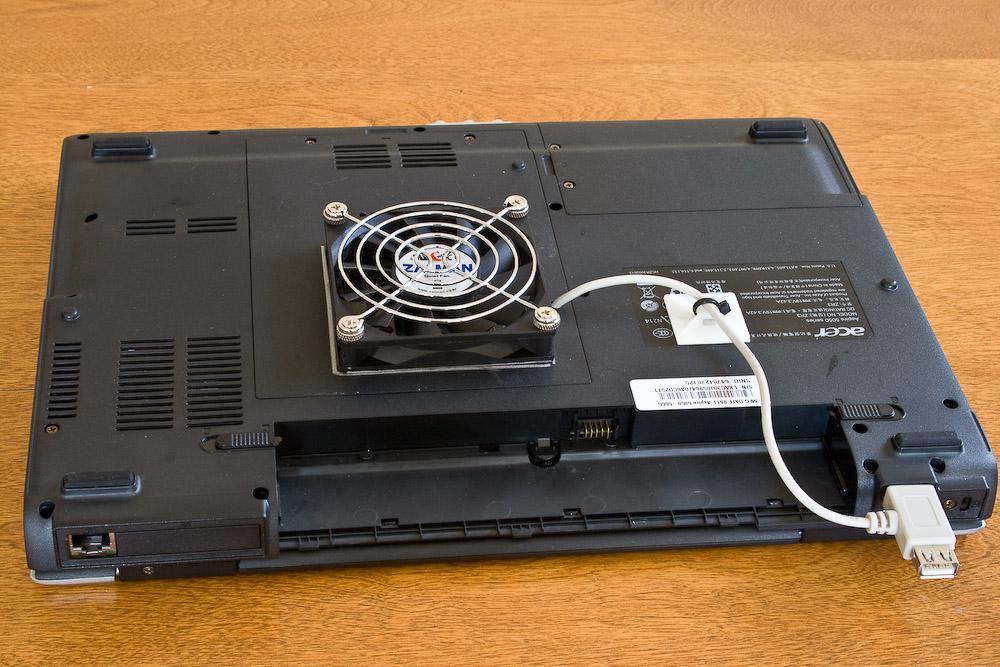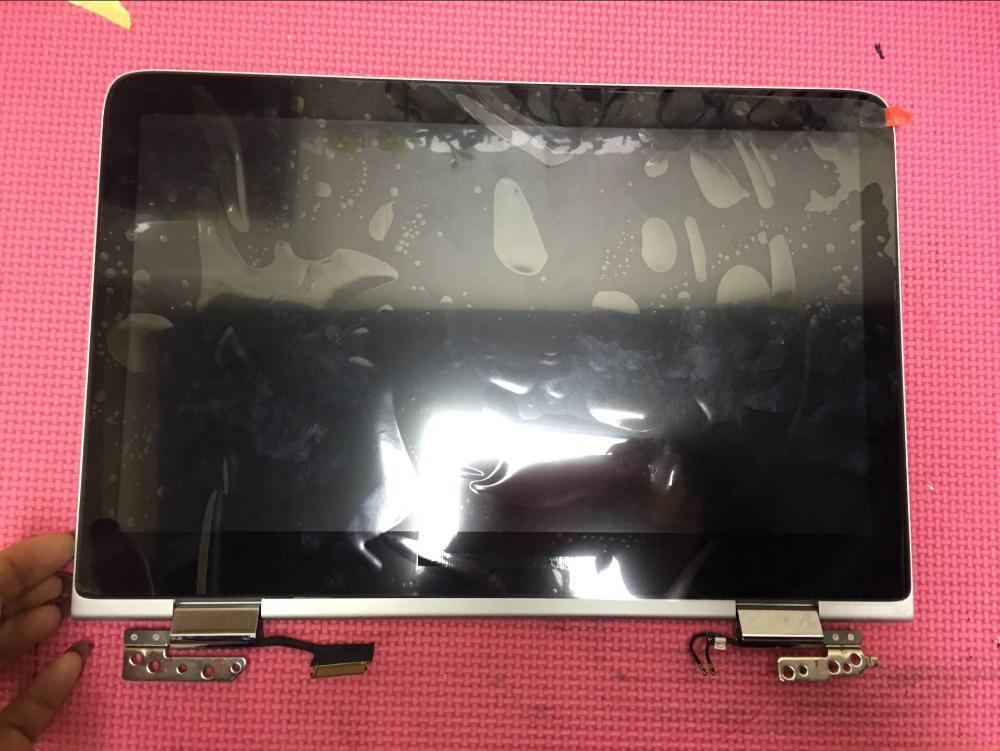The first image is the image on the left, the second image is the image on the right. Analyze the images presented: Is the assertion "An image shows one open laptop with at least one hand visible at a side of the image." valid? Answer yes or no. No. The first image is the image on the left, the second image is the image on the right. Given the left and right images, does the statement "At least one human hand is near a laptop in the right image." hold true? Answer yes or no. No. 